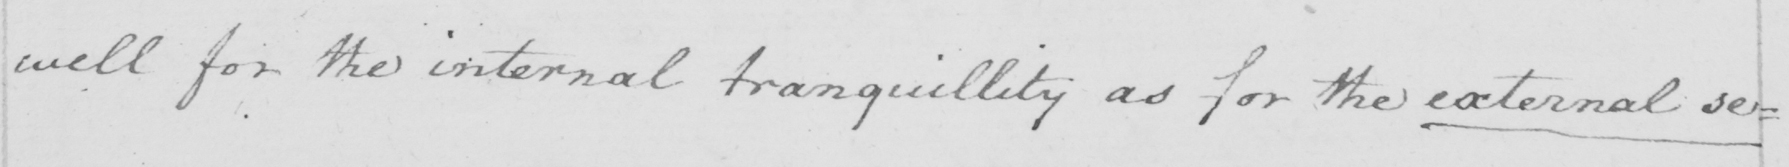Can you tell me what this handwritten text says? well for the internal tranquillity as for the external se= 